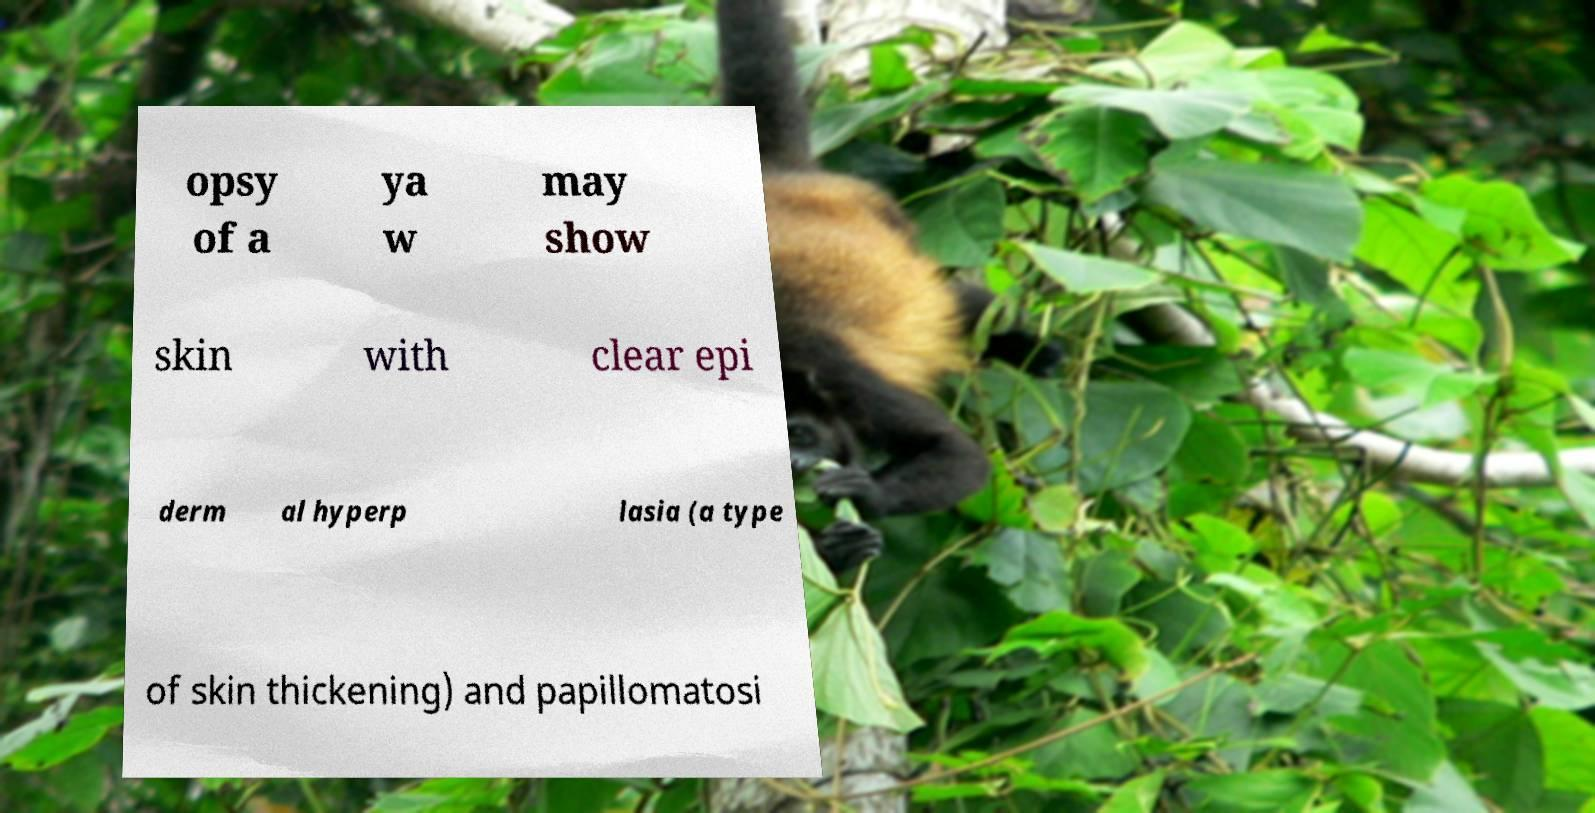What messages or text are displayed in this image? I need them in a readable, typed format. opsy of a ya w may show skin with clear epi derm al hyperp lasia (a type of skin thickening) and papillomatosi 